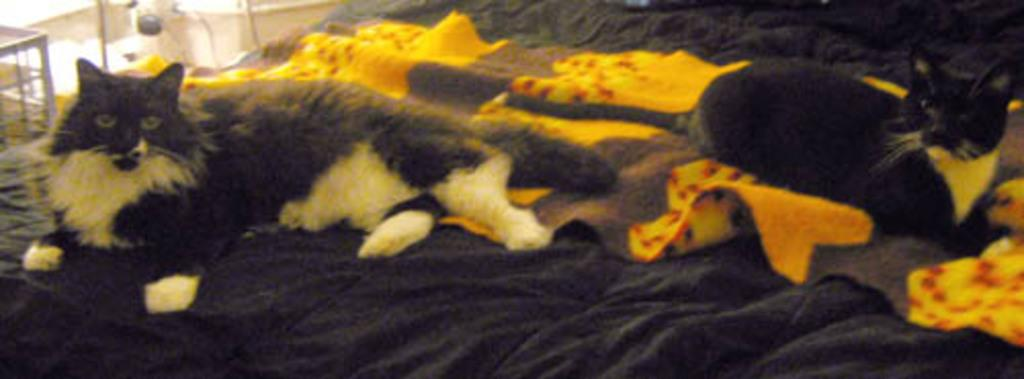What animals are lying in the image? There are cats lying in the image. What is at the bottom of the image? There is cloth at the bottom of the image. What structure can be seen in the background of the image? There is a table in the background of the image. What type of surface is visible in the image? There is a floor visible in the image. What type of government is depicted in the image? There is no government depicted in the image; it features cats lying on cloth. What advertisement can be seen on the table in the image? There is no advertisement present in the image; it only shows a table in the background. 